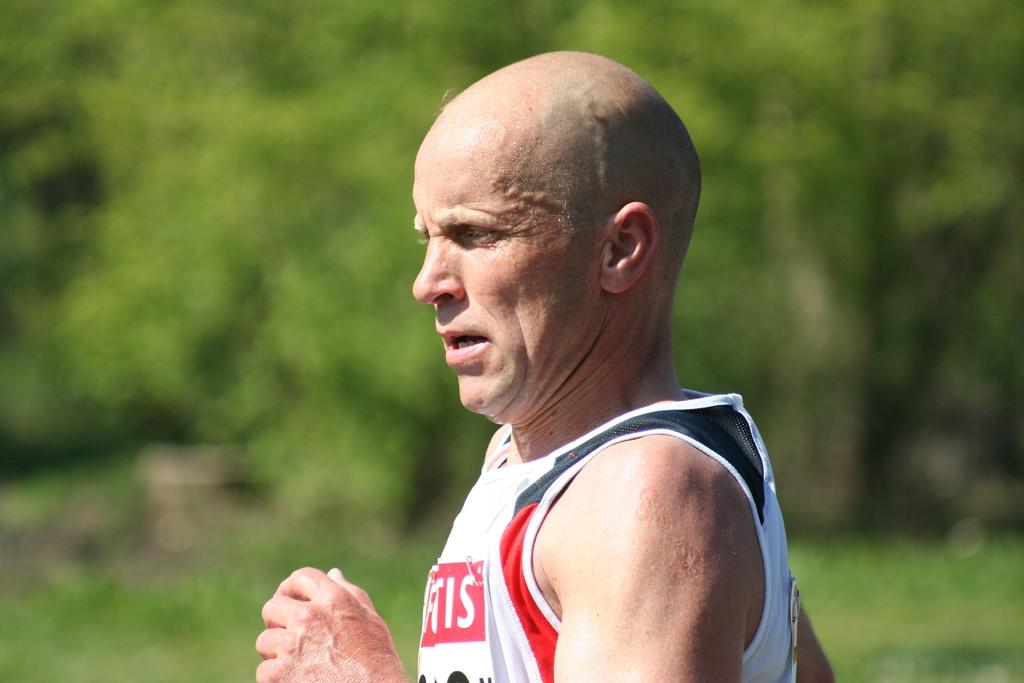<image>
Share a concise interpretation of the image provided. "IS" are the last two letters of the sponsor of this race. 